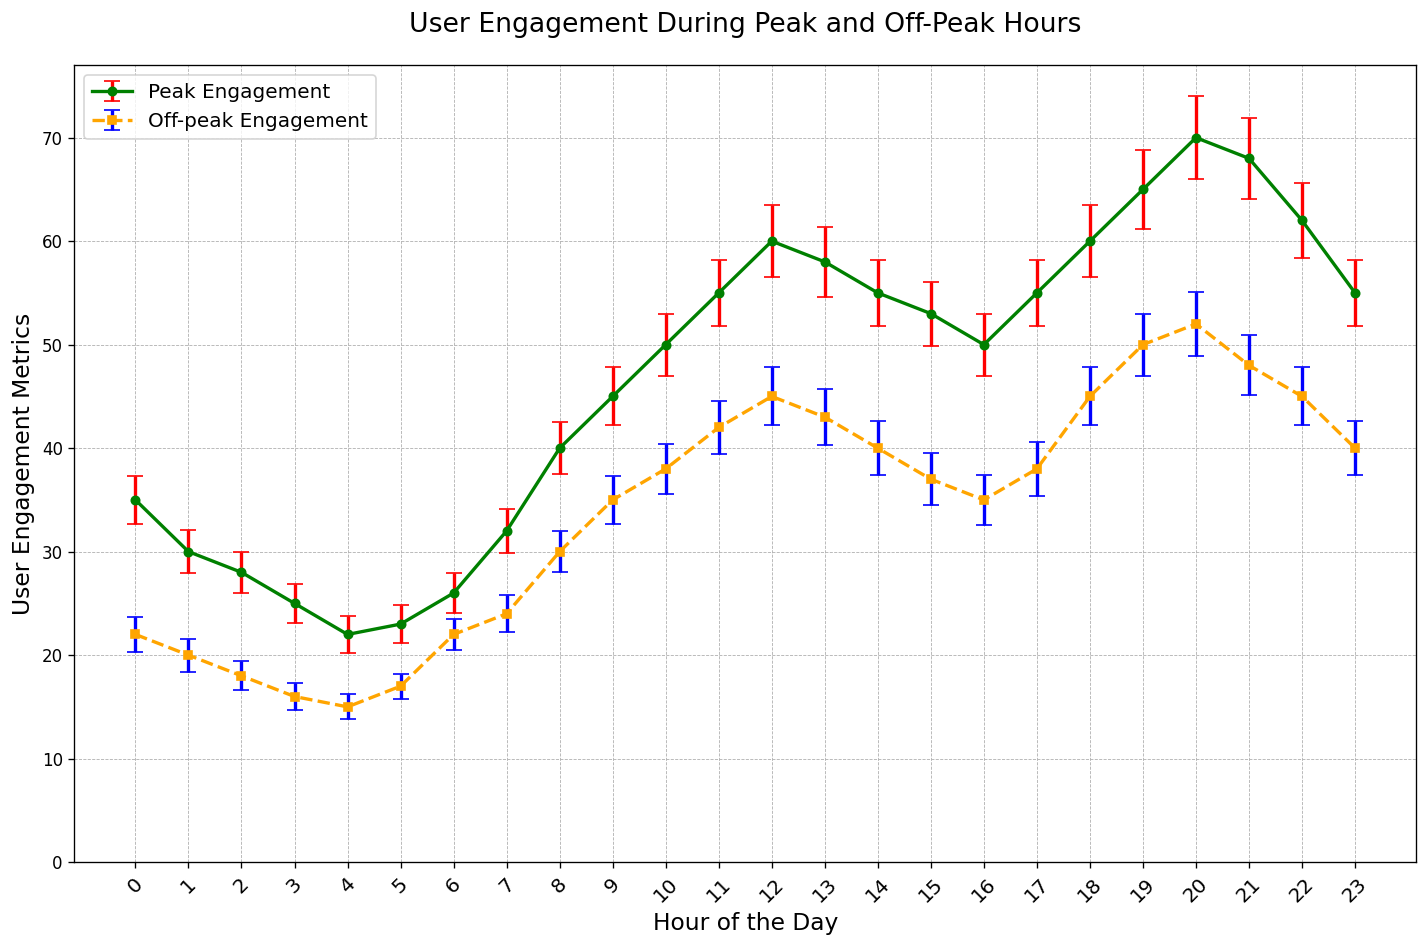What is the user engagement metric at 8 AM during peak and off-peak hours? Look for the values at the 8 AM mark on both the peak and off-peak lines. The plot shows mean_peak_engagement at 8 AM is 40 with a std_error_peak of 2.5, and mean_offpeak_engagement is 30 with a std_error_offpeak of 2.0
Answer: 40 (peak), 30 (off-peak) How does the user engagement at 12 PM during peak hours compare to off-peak hours? Locate 12 PM on the x-axis and compare the corresponding values of the peak and off-peak lines. The peak user engagement is 60, whereas during off-peak it is 45
Answer: Peak hours have 15 more user engagement What is the difference in peak user engagement metrics between 3 PM and 10 AM? Find the values for peak engagement at 3 PM and 10 AM. The peak user engagement at 3 PM is 55 and at 10 AM is 50. Subtract these values to determine the difference
Answer: 5 At what hour does the peak user engagement first exceed 50? Identify the earliest hour where the mean_peak_engagement value surpasses 50. According to the plot, this occurs first at 10 AM
Answer: 10 AM What are the visual differences between the error bars for peak and off-peak engagements? Observe the visual characteristics of the error bars. Peak engagement error bars are in red and off-peak error bars are in blue. The peak engagement error bars are generally larger, indicating more variability than the off-peak error bars
Answer: Color and size (peak: red, larger; off-peak: blue, smaller) Which hour shows the highest user engagement during peak hours and what is the corresponding value? Identify the hour with the highest point on the peak engagement line. This occurs at 8 PM with a value of 70
Answer: 8 PM, 70 During what hours does the peak user engagement remain constant, and what is the constant value? Identify the range with no change in the peak user engagement values. From 11 PM to 1 AM, the engagement remains at 55
Answer: 11 PM - 1 AM, 55 What is the trend of off-peak user engagement from 5 AM to 8 AM? Look at the off-peak engagement line between 5 AM and 8 AM. There's an increasing trend in user engagement from 17 to 30
Answer: Increasing What is the average peak user engagement metric across all hours? Sum up all peak engagement values and divide by the total number of hours. Total peak engagement is 1160, and there are 24 hours, so the average is 1160 / 24 = 48.33
Answer: 48.33 